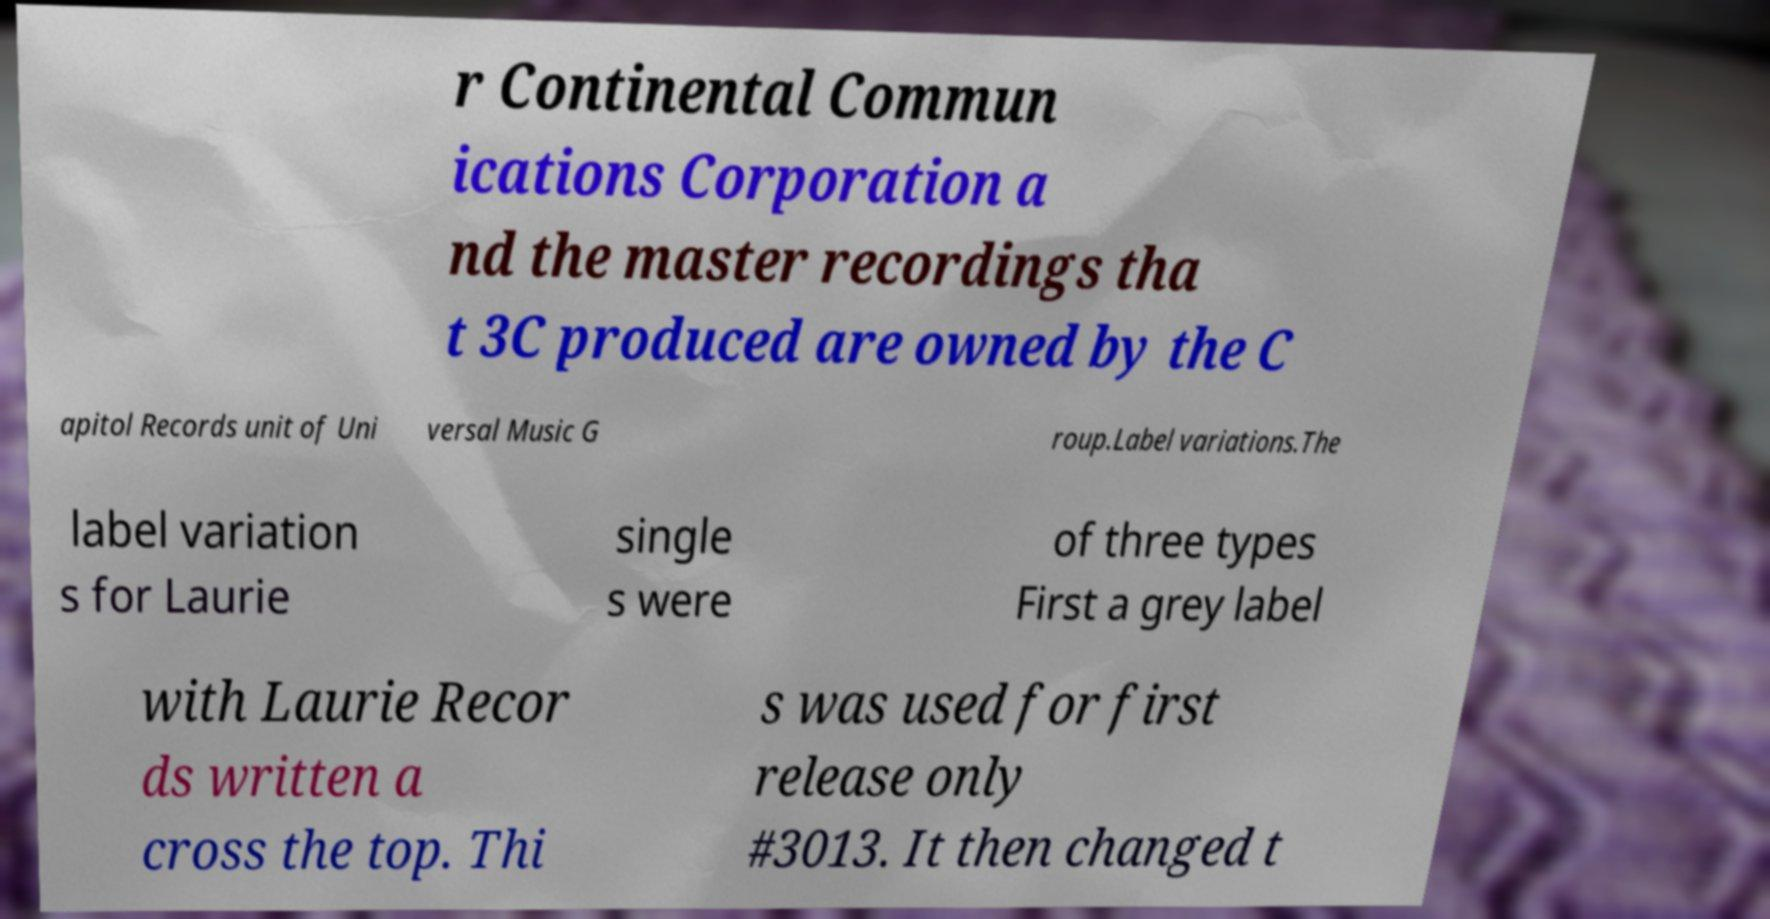What messages or text are displayed in this image? I need them in a readable, typed format. r Continental Commun ications Corporation a nd the master recordings tha t 3C produced are owned by the C apitol Records unit of Uni versal Music G roup.Label variations.The label variation s for Laurie single s were of three types First a grey label with Laurie Recor ds written a cross the top. Thi s was used for first release only #3013. It then changed t 